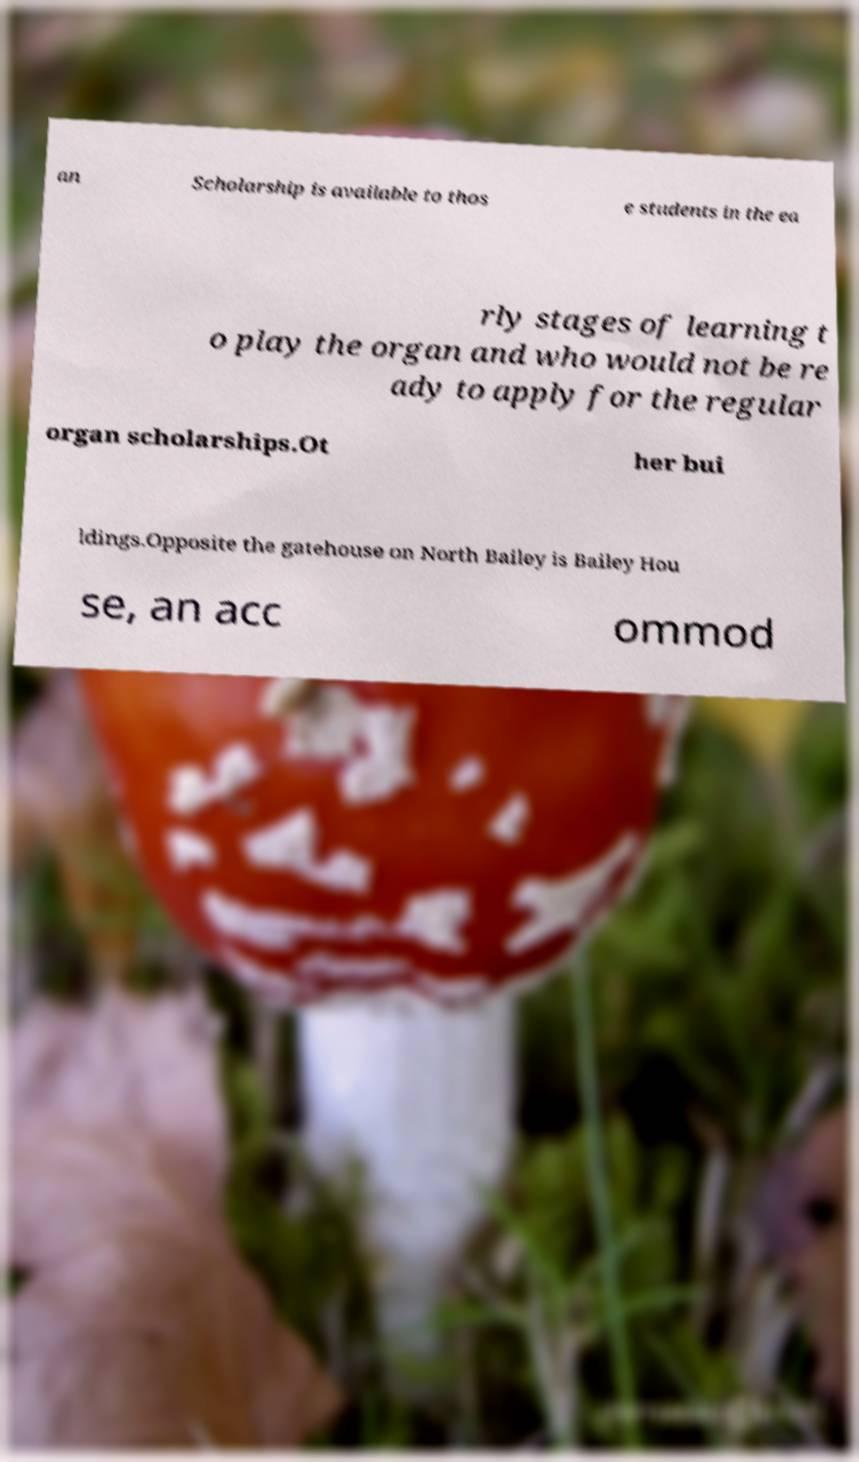Can you accurately transcribe the text from the provided image for me? an Scholarship is available to thos e students in the ea rly stages of learning t o play the organ and who would not be re ady to apply for the regular organ scholarships.Ot her bui ldings.Opposite the gatehouse on North Bailey is Bailey Hou se, an acc ommod 